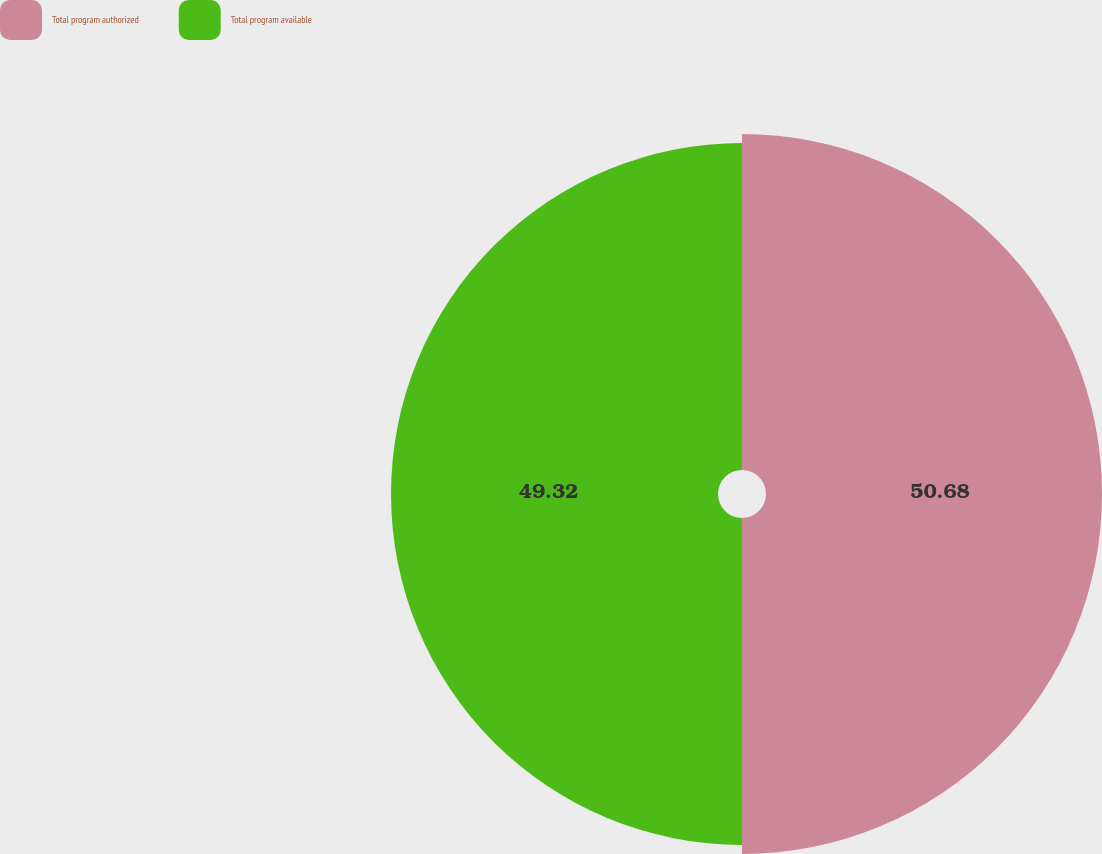<chart> <loc_0><loc_0><loc_500><loc_500><pie_chart><fcel>Total program authorized<fcel>Total program available<nl><fcel>50.68%<fcel>49.32%<nl></chart> 